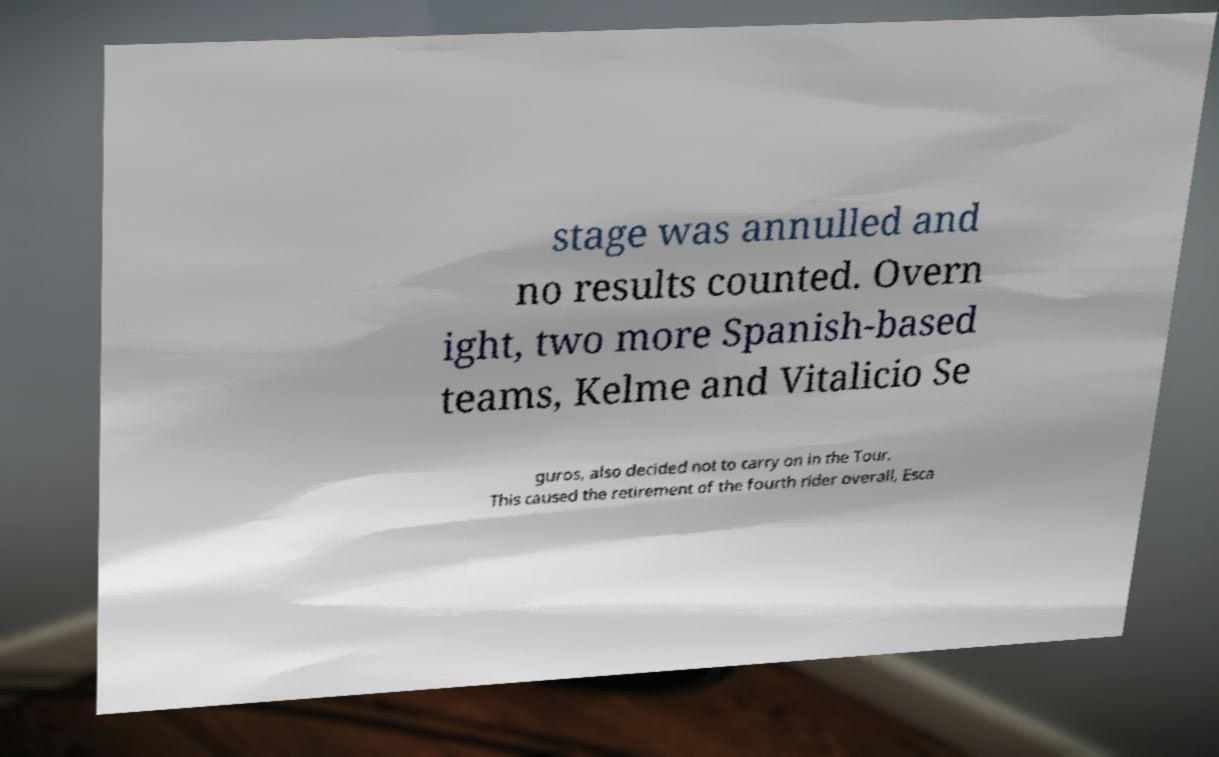What messages or text are displayed in this image? I need them in a readable, typed format. stage was annulled and no results counted. Overn ight, two more Spanish-based teams, Kelme and Vitalicio Se guros, also decided not to carry on in the Tour. This caused the retirement of the fourth rider overall, Esca 